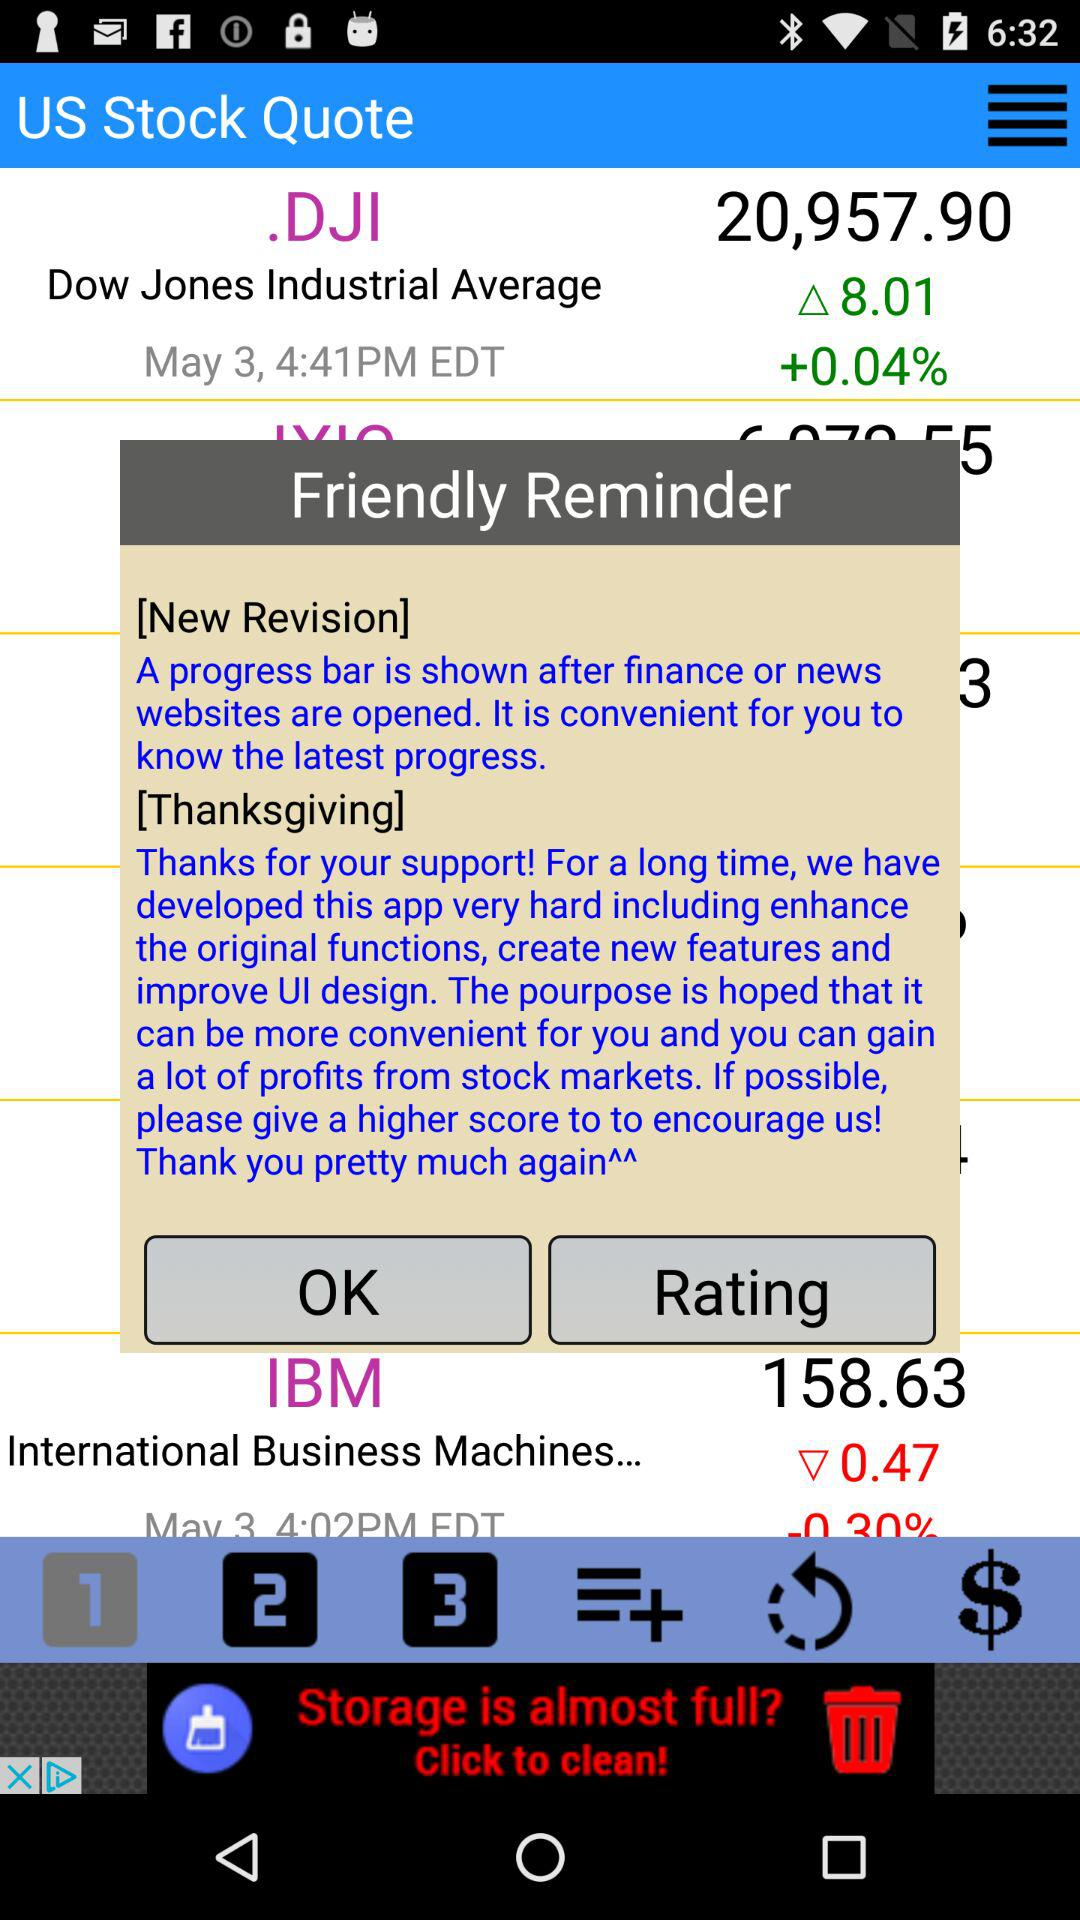What is the stock price of.DJI on May 3rd? The stock price of.DJI is 20,957.90. 